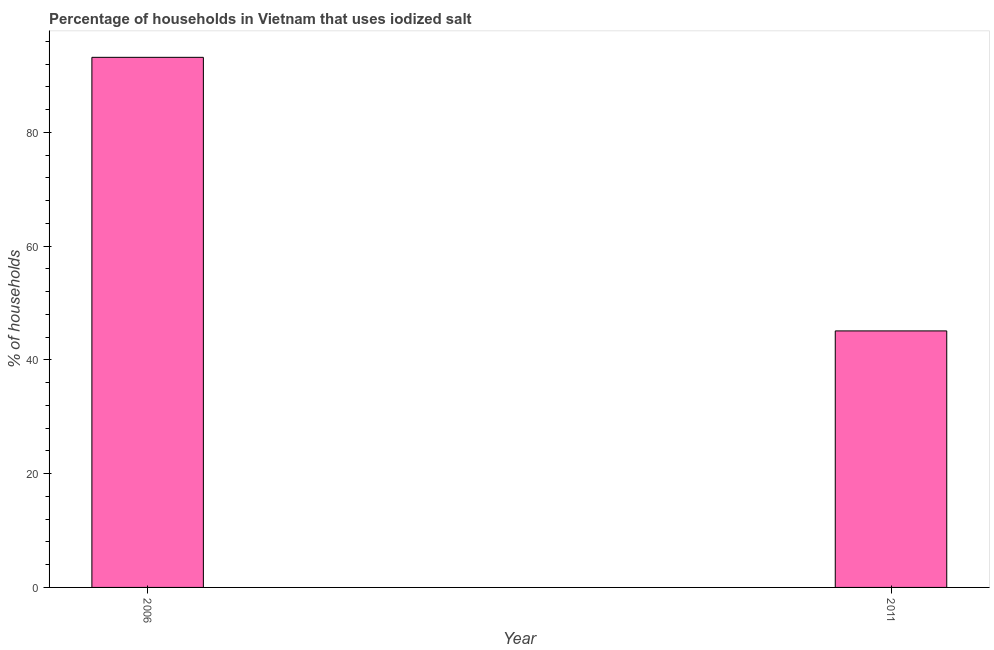Does the graph contain any zero values?
Give a very brief answer. No. What is the title of the graph?
Offer a very short reply. Percentage of households in Vietnam that uses iodized salt. What is the label or title of the Y-axis?
Make the answer very short. % of households. What is the percentage of households where iodized salt is consumed in 2011?
Keep it short and to the point. 45.1. Across all years, what is the maximum percentage of households where iodized salt is consumed?
Give a very brief answer. 93.2. Across all years, what is the minimum percentage of households where iodized salt is consumed?
Keep it short and to the point. 45.1. What is the sum of the percentage of households where iodized salt is consumed?
Provide a short and direct response. 138.3. What is the difference between the percentage of households where iodized salt is consumed in 2006 and 2011?
Your response must be concise. 48.1. What is the average percentage of households where iodized salt is consumed per year?
Offer a terse response. 69.15. What is the median percentage of households where iodized salt is consumed?
Give a very brief answer. 69.15. Do a majority of the years between 2011 and 2006 (inclusive) have percentage of households where iodized salt is consumed greater than 16 %?
Provide a short and direct response. No. What is the ratio of the percentage of households where iodized salt is consumed in 2006 to that in 2011?
Give a very brief answer. 2.07. Is the percentage of households where iodized salt is consumed in 2006 less than that in 2011?
Ensure brevity in your answer.  No. In how many years, is the percentage of households where iodized salt is consumed greater than the average percentage of households where iodized salt is consumed taken over all years?
Your answer should be very brief. 1. How many bars are there?
Your answer should be very brief. 2. How many years are there in the graph?
Your answer should be compact. 2. Are the values on the major ticks of Y-axis written in scientific E-notation?
Make the answer very short. No. What is the % of households in 2006?
Give a very brief answer. 93.2. What is the % of households in 2011?
Your answer should be very brief. 45.1. What is the difference between the % of households in 2006 and 2011?
Make the answer very short. 48.1. What is the ratio of the % of households in 2006 to that in 2011?
Your response must be concise. 2.07. 